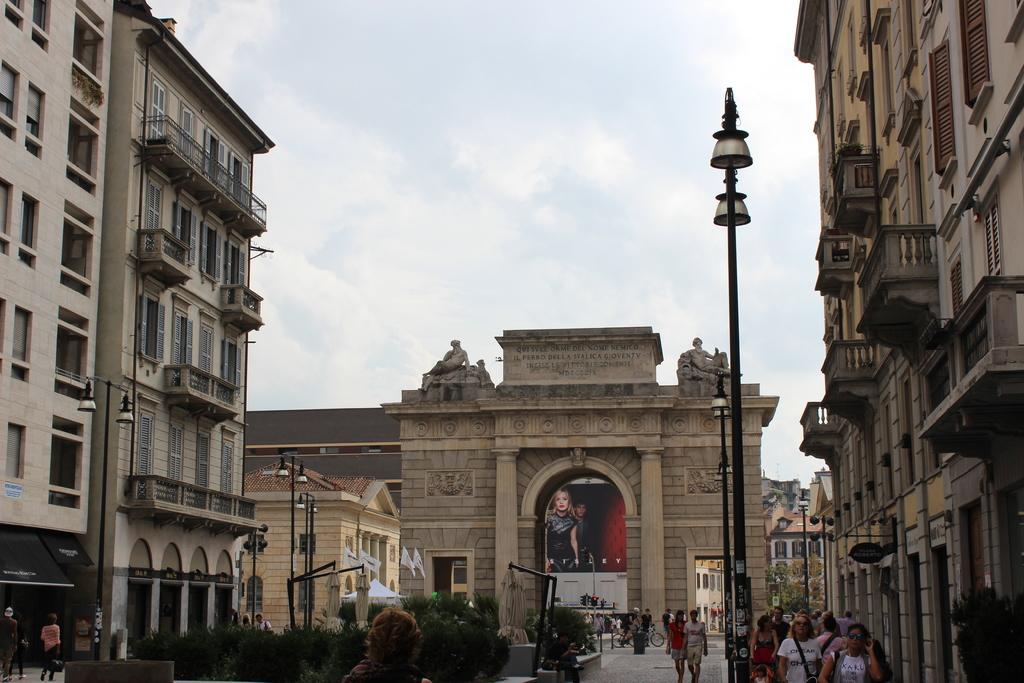What are the people in the image doing? The people in the image are walking on the ground. What can be seen in the distance in the image? There are buildings, street lights, plants, and the sky visible in the background of the image. What else is present on the ground in the image? There are other objects on the ground in the image. Can you see any signs of growth on the swing in the image? There is no swing present in the image. What type of space vehicle can be seen in the image? There is no space vehicle present in the image. 